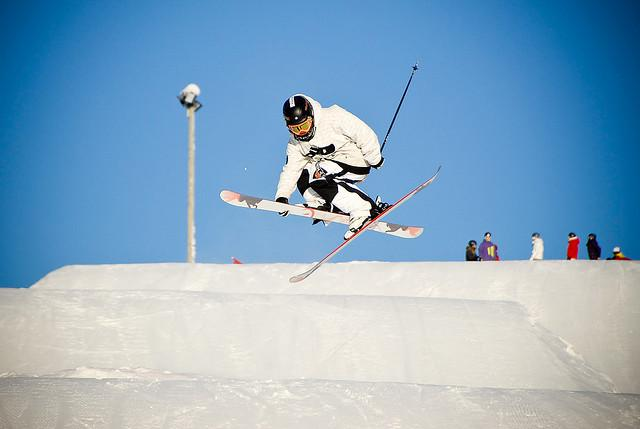Why is the man holding onto the ski?

Choices:
A) performing trick
B) cleaning it
C) waxing it
D) unlatching performing trick 